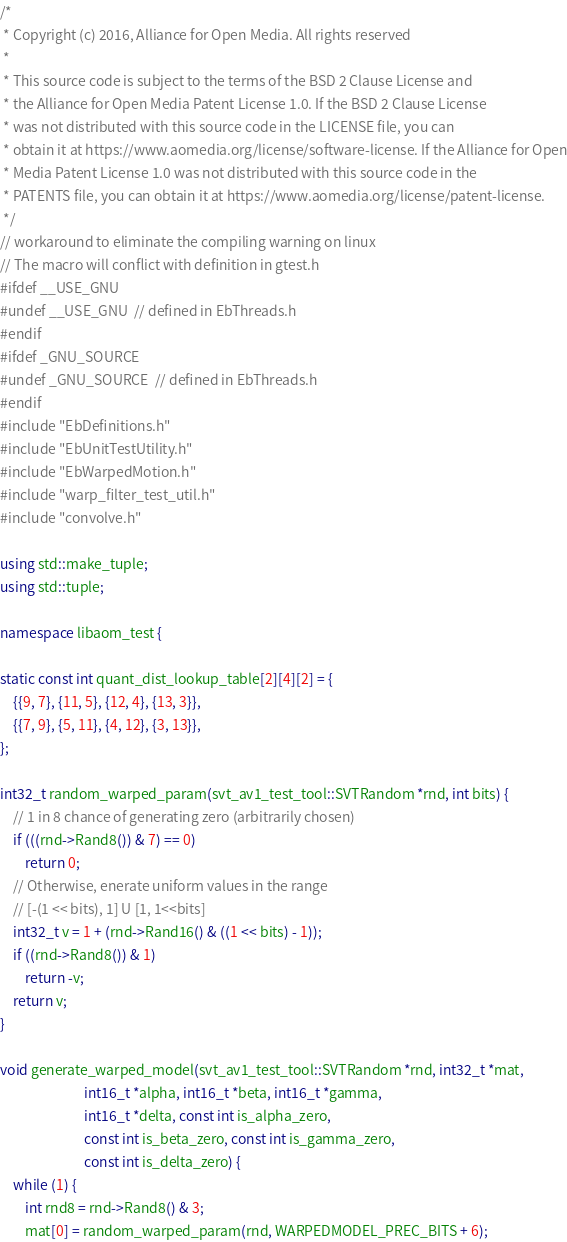Convert code to text. <code><loc_0><loc_0><loc_500><loc_500><_C++_>/*
 * Copyright (c) 2016, Alliance for Open Media. All rights reserved
 *
 * This source code is subject to the terms of the BSD 2 Clause License and
 * the Alliance for Open Media Patent License 1.0. If the BSD 2 Clause License
 * was not distributed with this source code in the LICENSE file, you can
 * obtain it at https://www.aomedia.org/license/software-license. If the Alliance for Open
 * Media Patent License 1.0 was not distributed with this source code in the
 * PATENTS file, you can obtain it at https://www.aomedia.org/license/patent-license.
 */
// workaround to eliminate the compiling warning on linux
// The macro will conflict with definition in gtest.h
#ifdef __USE_GNU
#undef __USE_GNU  // defined in EbThreads.h
#endif
#ifdef _GNU_SOURCE
#undef _GNU_SOURCE  // defined in EbThreads.h
#endif
#include "EbDefinitions.h"
#include "EbUnitTestUtility.h"
#include "EbWarpedMotion.h"
#include "warp_filter_test_util.h"
#include "convolve.h"

using std::make_tuple;
using std::tuple;

namespace libaom_test {

static const int quant_dist_lookup_table[2][4][2] = {
    {{9, 7}, {11, 5}, {12, 4}, {13, 3}},
    {{7, 9}, {5, 11}, {4, 12}, {3, 13}},
};

int32_t random_warped_param(svt_av1_test_tool::SVTRandom *rnd, int bits) {
    // 1 in 8 chance of generating zero (arbitrarily chosen)
    if (((rnd->Rand8()) & 7) == 0)
        return 0;
    // Otherwise, enerate uniform values in the range
    // [-(1 << bits), 1] U [1, 1<<bits]
    int32_t v = 1 + (rnd->Rand16() & ((1 << bits) - 1));
    if ((rnd->Rand8()) & 1)
        return -v;
    return v;
}

void generate_warped_model(svt_av1_test_tool::SVTRandom *rnd, int32_t *mat,
                           int16_t *alpha, int16_t *beta, int16_t *gamma,
                           int16_t *delta, const int is_alpha_zero,
                           const int is_beta_zero, const int is_gamma_zero,
                           const int is_delta_zero) {
    while (1) {
        int rnd8 = rnd->Rand8() & 3;
        mat[0] = random_warped_param(rnd, WARPEDMODEL_PREC_BITS + 6);</code> 